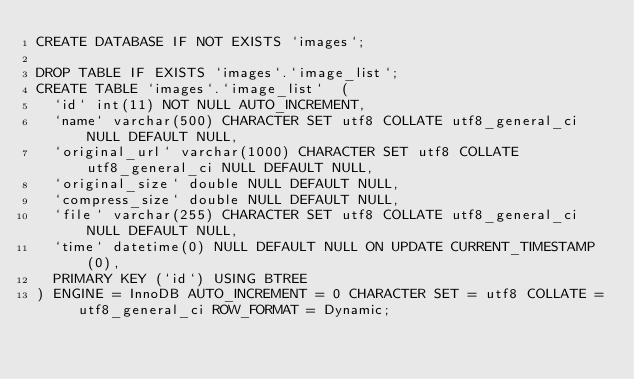<code> <loc_0><loc_0><loc_500><loc_500><_SQL_>CREATE DATABASE IF NOT EXISTS `images`;

DROP TABLE IF EXISTS `images`.`image_list`;
CREATE TABLE `images`.`image_list`  (
  `id` int(11) NOT NULL AUTO_INCREMENT,
  `name` varchar(500) CHARACTER SET utf8 COLLATE utf8_general_ci NULL DEFAULT NULL,
  `original_url` varchar(1000) CHARACTER SET utf8 COLLATE utf8_general_ci NULL DEFAULT NULL,
  `original_size` double NULL DEFAULT NULL,
  `compress_size` double NULL DEFAULT NULL,
  `file` varchar(255) CHARACTER SET utf8 COLLATE utf8_general_ci NULL DEFAULT NULL,
  `time` datetime(0) NULL DEFAULT NULL ON UPDATE CURRENT_TIMESTAMP(0),
  PRIMARY KEY (`id`) USING BTREE
) ENGINE = InnoDB AUTO_INCREMENT = 0 CHARACTER SET = utf8 COLLATE = utf8_general_ci ROW_FORMAT = Dynamic;
</code> 